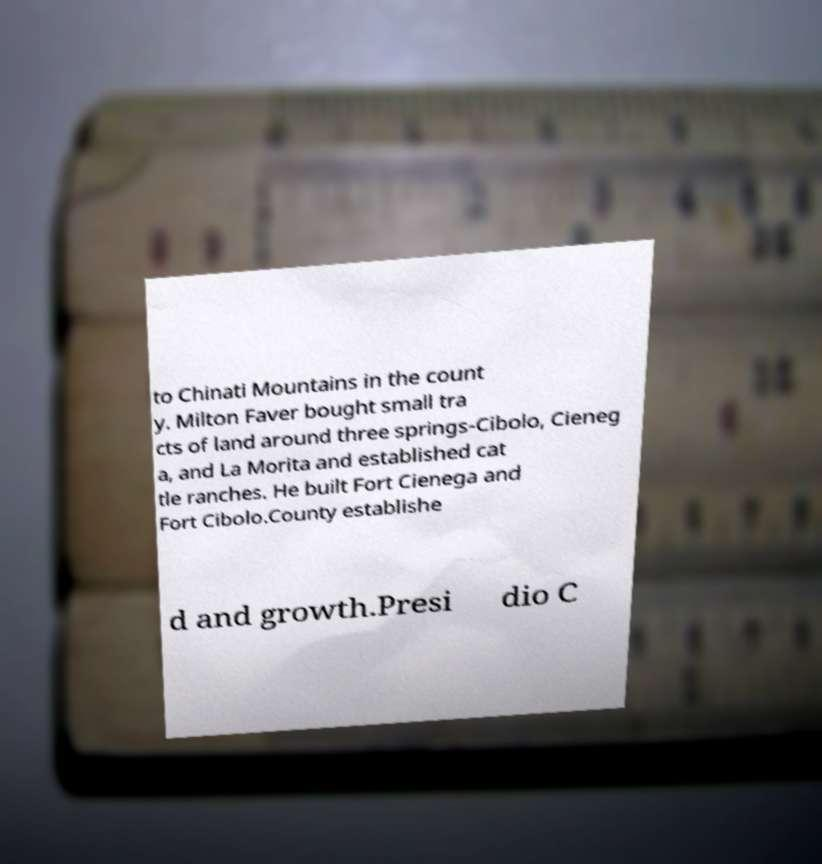For documentation purposes, I need the text within this image transcribed. Could you provide that? to Chinati Mountains in the count y. Milton Faver bought small tra cts of land around three springs-Cibolo, Cieneg a, and La Morita and established cat tle ranches. He built Fort Cienega and Fort Cibolo.County establishe d and growth.Presi dio C 